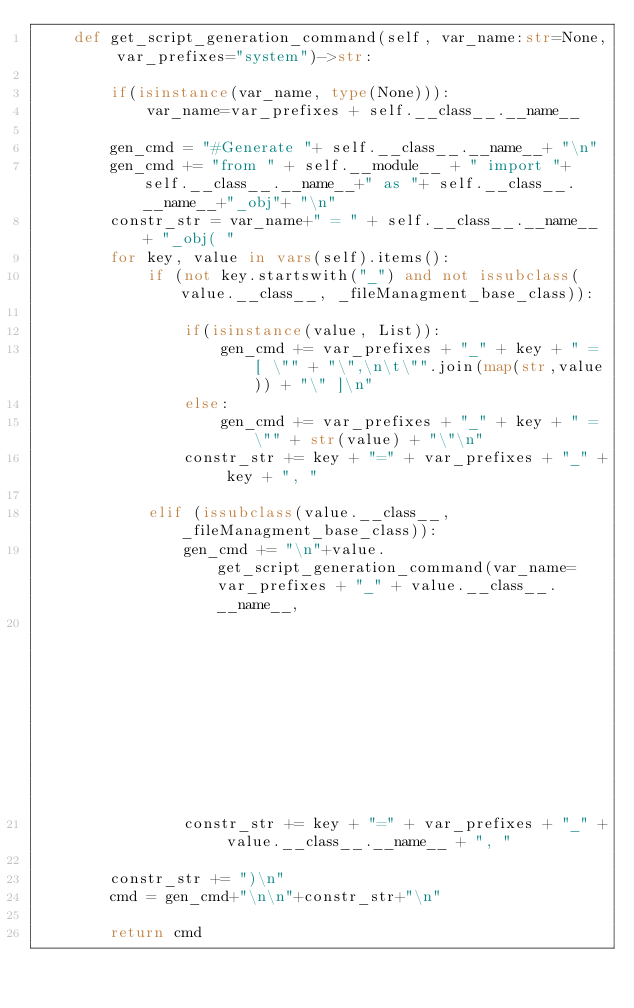<code> <loc_0><loc_0><loc_500><loc_500><_Python_>    def get_script_generation_command(self, var_name:str=None, var_prefixes="system")->str:

        if(isinstance(var_name, type(None))):
            var_name=var_prefixes + self.__class__.__name__

        gen_cmd = "#Generate "+ self.__class__.__name__+ "\n"
        gen_cmd += "from " + self.__module__ + " import "+ self.__class__.__name__+" as "+ self.__class__.__name__+"_obj"+ "\n"
        constr_str = var_name+" = " + self.__class__.__name__ + "_obj( "
        for key, value in vars(self).items():
            if (not key.startswith("_") and not issubclass(value.__class__, _fileManagment_base_class)):

                if(isinstance(value, List)):
                    gen_cmd += var_prefixes + "_" + key + " = [ \"" + "\",\n\t\"".join(map(str,value)) + "\" ]\n"
                else:
                    gen_cmd += var_prefixes + "_" + key + " = \"" + str(value) + "\"\n"
                constr_str += key + "=" + var_prefixes + "_" + key + ", "

            elif (issubclass(value.__class__, _fileManagment_base_class)):
                gen_cmd += "\n"+value.get_script_generation_command(var_name= var_prefixes + "_" + value.__class__.__name__,
                                                                    var_prefixes=var_prefixes)+ "\n"
                constr_str += key + "=" + var_prefixes + "_" + value.__class__.__name__ + ", "

        constr_str += ")\n"
        cmd = gen_cmd+"\n\n"+constr_str+"\n"

        return cmd</code> 